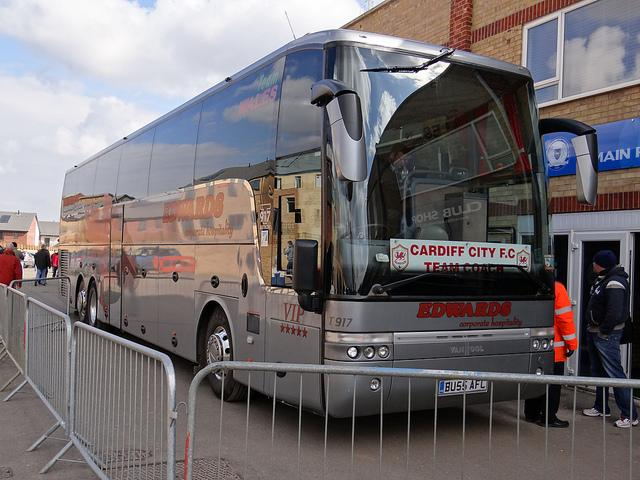Why is the man wearing an orange vest? visibility 